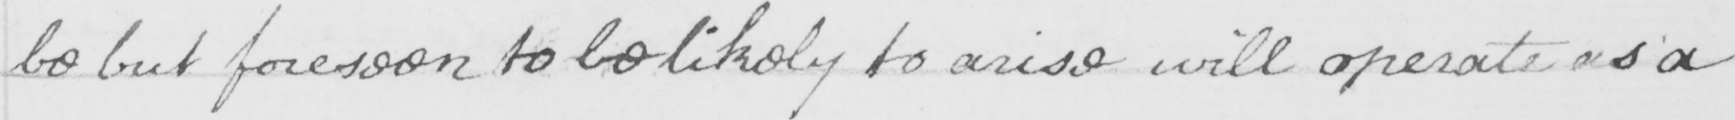Transcribe the text shown in this historical manuscript line. be but foreseen to be likely to arise will operate as a 